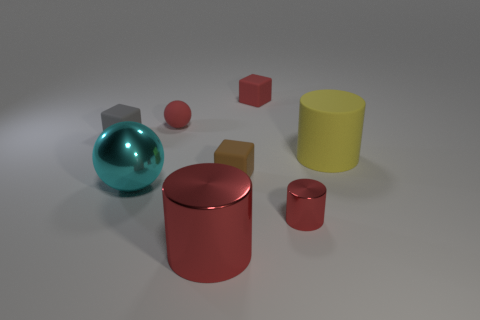Subtract all matte cylinders. How many cylinders are left? 2 Subtract all red cubes. How many cubes are left? 2 Subtract all balls. How many objects are left? 6 Subtract 1 balls. How many balls are left? 1 Add 2 green matte cylinders. How many objects exist? 10 Subtract all gray spheres. How many red cylinders are left? 2 Add 7 large balls. How many large balls exist? 8 Subtract 0 green blocks. How many objects are left? 8 Subtract all yellow cylinders. Subtract all red blocks. How many cylinders are left? 2 Subtract all cyan balls. Subtract all red matte cubes. How many objects are left? 6 